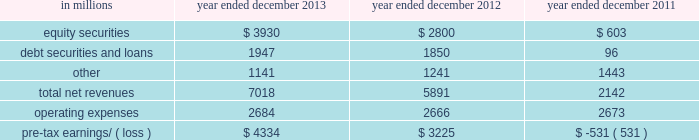Management 2019s discussion and analysis net revenues in equities were $ 8.21 billion for 2012 , essentially unchanged compared with 2011 .
Net revenues in securities services were significantly higher compared with 2011 , reflecting a gain of $ 494 million on the sale of our hedge fund administration business .
In addition , equities client execution net revenues were higher than 2011 , primarily reflecting significantly higher results in cash products , principally due to increased levels of client activity .
These increases were offset by lower commissions and fees , reflecting declines in the united states , europe and asia .
Our average daily volumes during 2012 were lower in each of these regions compared with 2011 , consistent with listed cash equity market volumes .
During 2012 , equities operated in an environment generally characterized by an increase in global equity prices and lower volatility levels .
The net loss attributable to the impact of changes in our own credit spreads on borrowings for which the fair value option was elected was $ 714 million ( $ 433 million and $ 281 million related to fixed income , currency and commodities client execution and equities client execution , respectively ) for 2012 , compared with a net gain of $ 596 million ( $ 399 million and $ 197 million related to fixed income , currency and commodities client execution and equities client execution , respectively ) for 2011 .
During 2012 , institutional client services operated in an environment generally characterized by continued broad market concerns and uncertainties , although positive developments helped to improve market conditions .
These developments included certain central bank actions to ease monetary policy and address funding risks for european financial institutions .
In addition , the u.s .
Economy posted stable to improving economic data , including favorable developments in unemployment and housing .
These improvements resulted in tighter credit spreads , higher global equity prices and lower levels of volatility .
However , concerns about the outlook for the global economy and continued political uncertainty , particularly the political debate in the united states surrounding the fiscal cliff , generally resulted in client risk aversion and lower activity levels .
Also , uncertainty over financial regulatory reform persisted .
Operating expenses were $ 12.48 billion for 2012 , 3% ( 3 % ) lower than 2011 , primarily due to lower brokerage , clearing , exchange and distribution fees , and lower impairment charges , partially offset by higher net provisions for litigation and regulatory proceedings .
Pre- tax earnings were $ 5.64 billion in 2012 , 27% ( 27 % ) higher than 2011 .
Investing & lending investing & lending includes our investing activities and the origination of loans to provide financing to clients .
These investments , some of which are consolidated , and loans are typically longer-term in nature .
We make investments , directly and indirectly through funds that we manage , in debt securities and loans , public and private equity securities , and real estate entities .
The table below presents the operating results of our investing & lending segment. .
2013 versus 2012 .
Net revenues in investing & lending were $ 7.02 billion for 2013 , 19% ( 19 % ) higher than 2012 , reflecting a significant increase in net gains from investments in equity securities , driven by company-specific events and stronger corporate performance , as well as significantly higher global equity prices .
In addition , net gains and net interest income from debt securities and loans were slightly higher , while other net revenues , related to our consolidated investments , were lower compared with 2012 .
If equity markets decline or credit spreads widen , net revenues in investing & lending would likely be negatively impacted .
Operating expenses were $ 2.68 billion for 2013 , essentially unchanged compared with 2012 .
Operating expenses during 2013 included lower impairment charges and lower operating expenses related to consolidated investments , partially offset by increased compensation and benefits expenses due to higher net revenues compared with 2012 .
Pre-tax earnings were $ 4.33 billion in 2013 , 34% ( 34 % ) higher than 2012 .
52 goldman sachs 2013 annual report .
What percentage of total net revenues investing & lending segment were attributable to equity securities in 2013? 
Computations: (3930 / 7018)
Answer: 0.55999. 